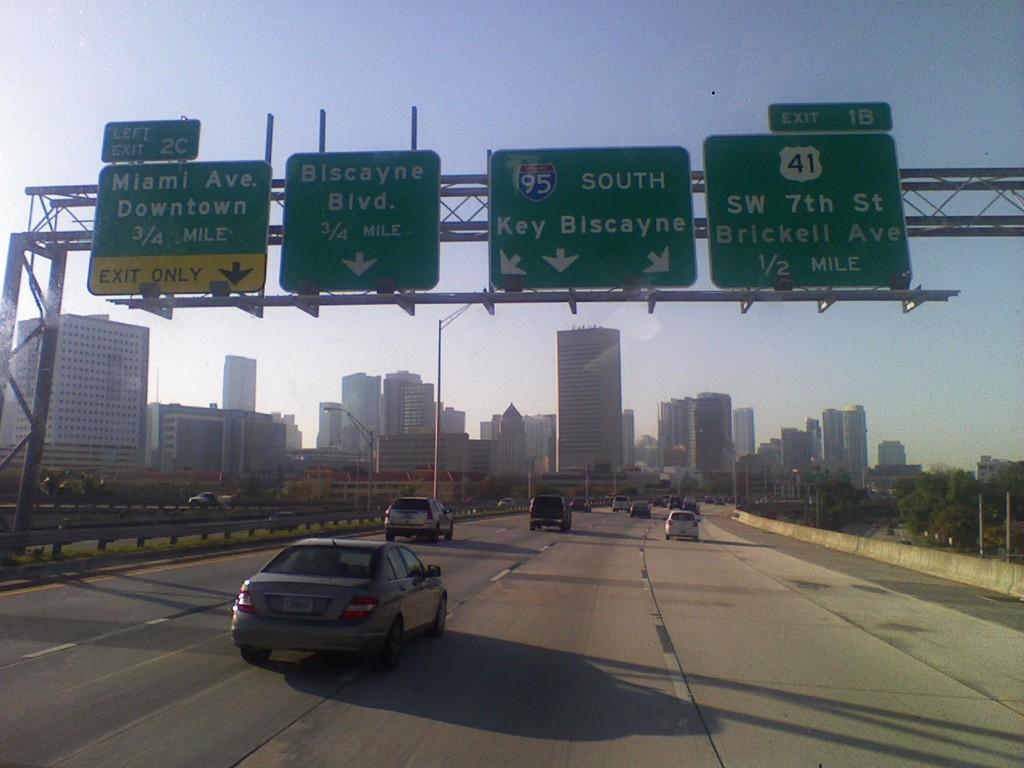Describe this image in one or two sentences. In this picture we can observe a road on which there are some cars. We can observe green color boards. There are trees and buildings. In the background there is a sky. 